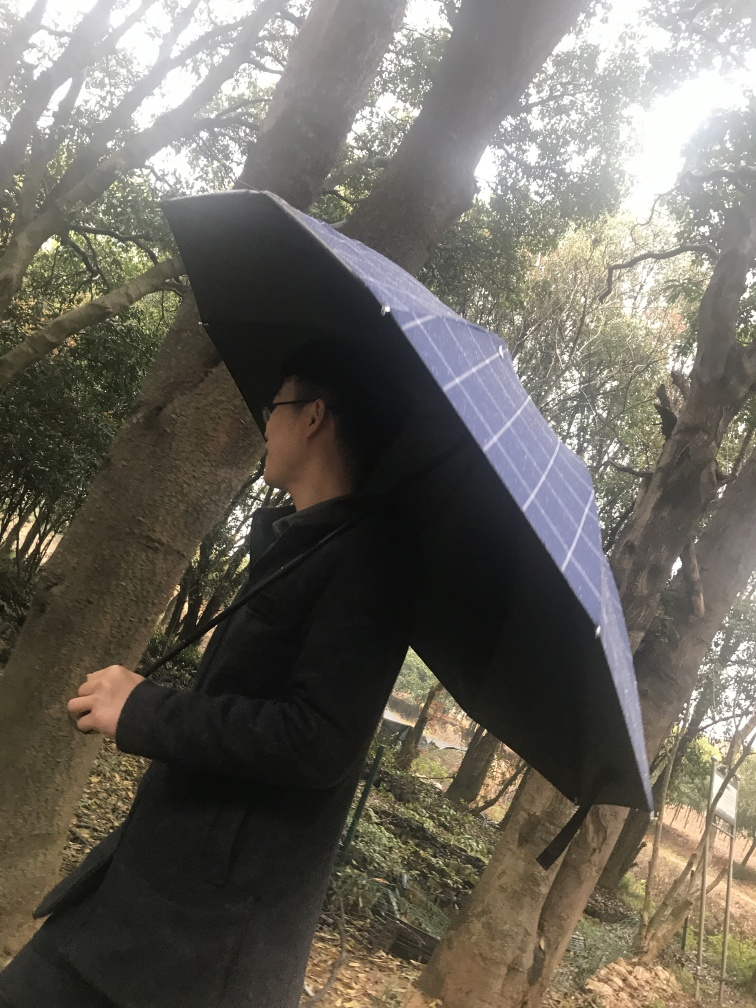Can you speculate about the reason for the person's presence in this location? Based on the image, the person could be out for a leisurely walk in a park, possibly enjoying a quiet moment alone. The natural setting and casual attire do not immediately suggest urgency or a work-related context. Instead, there's a sense of the person being there by choice, seeking a moment of serenity amidst nature. 